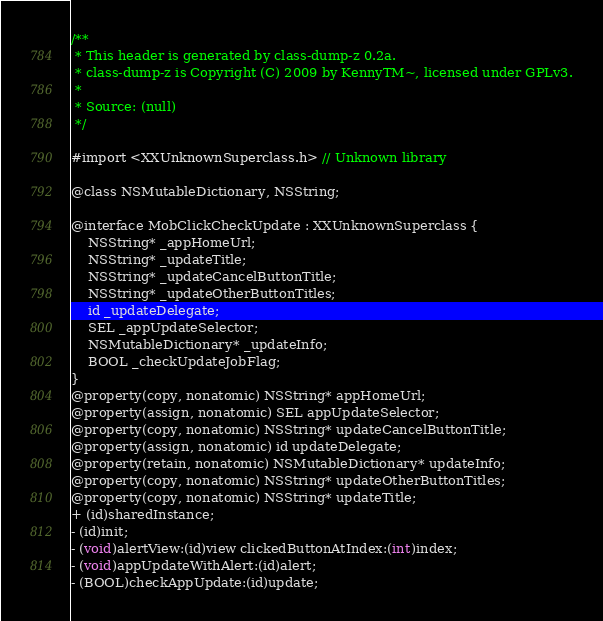<code> <loc_0><loc_0><loc_500><loc_500><_C_>/**
 * This header is generated by class-dump-z 0.2a.
 * class-dump-z is Copyright (C) 2009 by KennyTM~, licensed under GPLv3.
 *
 * Source: (null)
 */

#import <XXUnknownSuperclass.h> // Unknown library

@class NSMutableDictionary, NSString;

@interface MobClickCheckUpdate : XXUnknownSuperclass {
	NSString* _appHomeUrl;
	NSString* _updateTitle;
	NSString* _updateCancelButtonTitle;
	NSString* _updateOtherButtonTitles;
	id _updateDelegate;
	SEL _appUpdateSelector;
	NSMutableDictionary* _updateInfo;
	BOOL _checkUpdateJobFlag;
}
@property(copy, nonatomic) NSString* appHomeUrl;
@property(assign, nonatomic) SEL appUpdateSelector;
@property(copy, nonatomic) NSString* updateCancelButtonTitle;
@property(assign, nonatomic) id updateDelegate;
@property(retain, nonatomic) NSMutableDictionary* updateInfo;
@property(copy, nonatomic) NSString* updateOtherButtonTitles;
@property(copy, nonatomic) NSString* updateTitle;
+ (id)sharedInstance;
- (id)init;
- (void)alertView:(id)view clickedButtonAtIndex:(int)index;
- (void)appUpdateWithAlert:(id)alert;
- (BOOL)checkAppUpdate:(id)update;</code> 